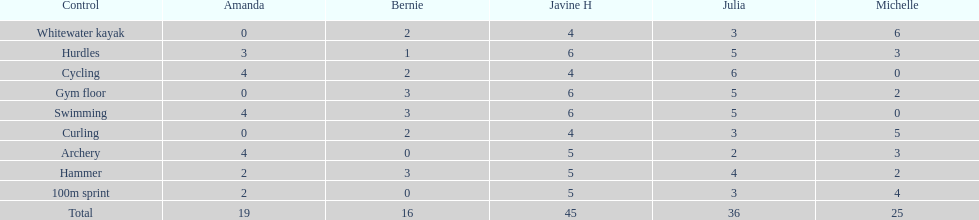Who earned the most total points? Javine H. 